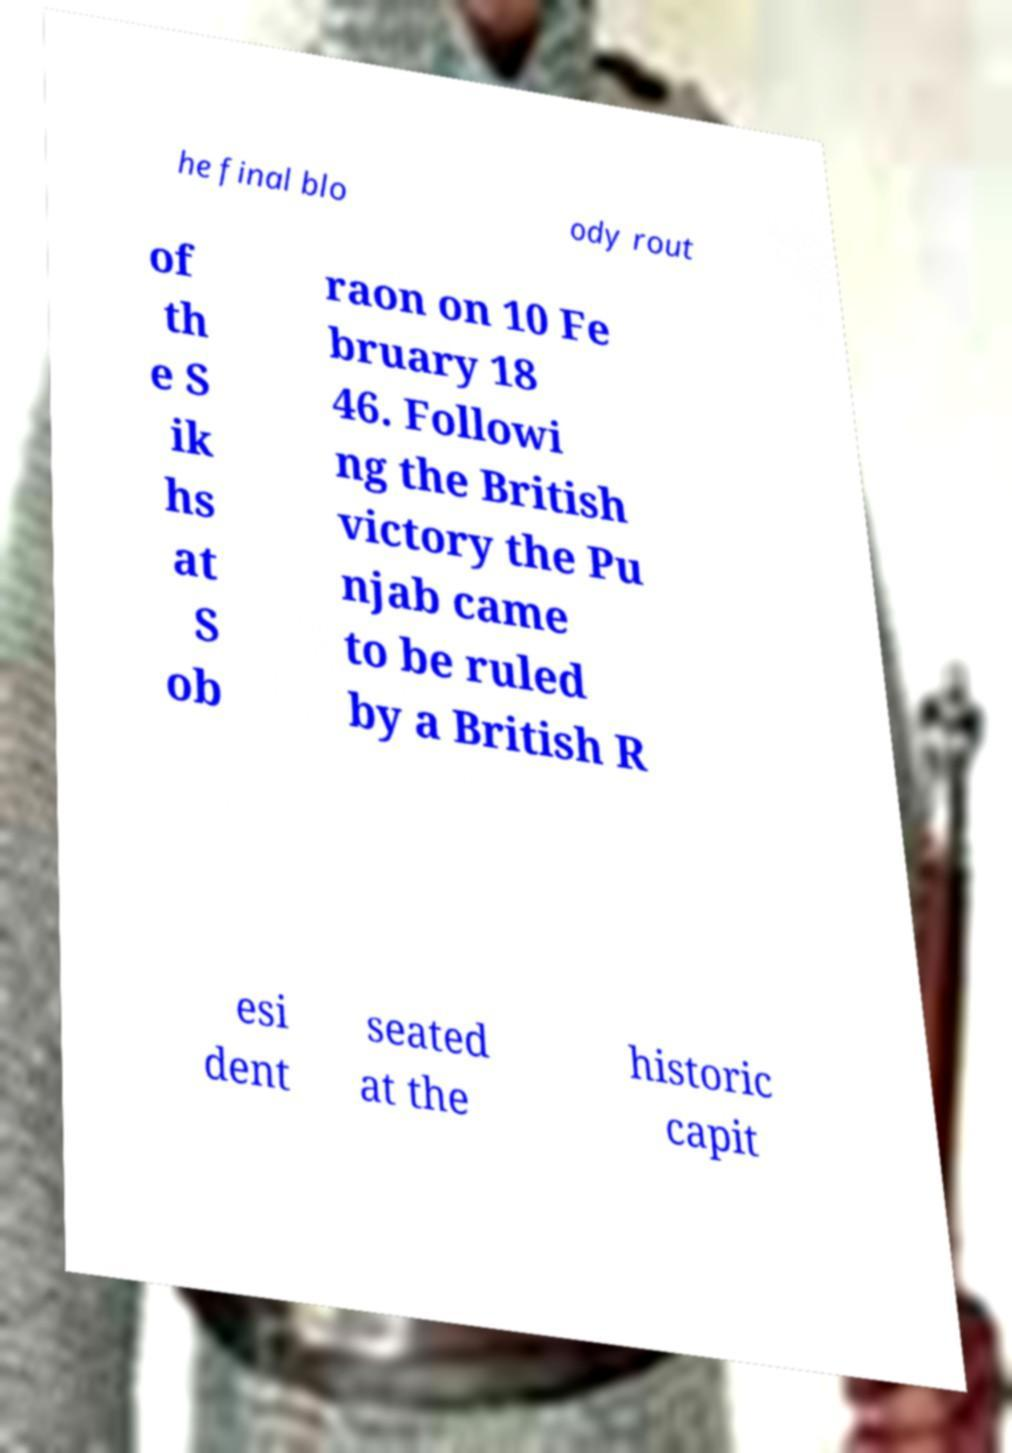What messages or text are displayed in this image? I need them in a readable, typed format. he final blo ody rout of th e S ik hs at S ob raon on 10 Fe bruary 18 46. Followi ng the British victory the Pu njab came to be ruled by a British R esi dent seated at the historic capit 